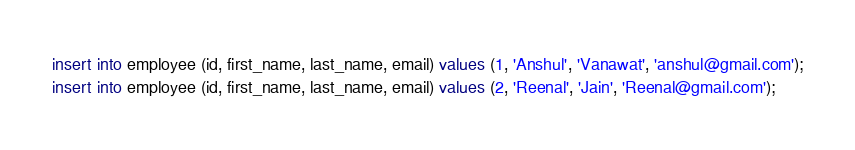Convert code to text. <code><loc_0><loc_0><loc_500><loc_500><_SQL_>insert into employee (id, first_name, last_name, email) values (1, 'Anshul', 'Vanawat', 'anshul@gmail.com');
insert into employee (id, first_name, last_name, email) values (2, 'Reenal', 'Jain', 'Reenal@gmail.com');</code> 